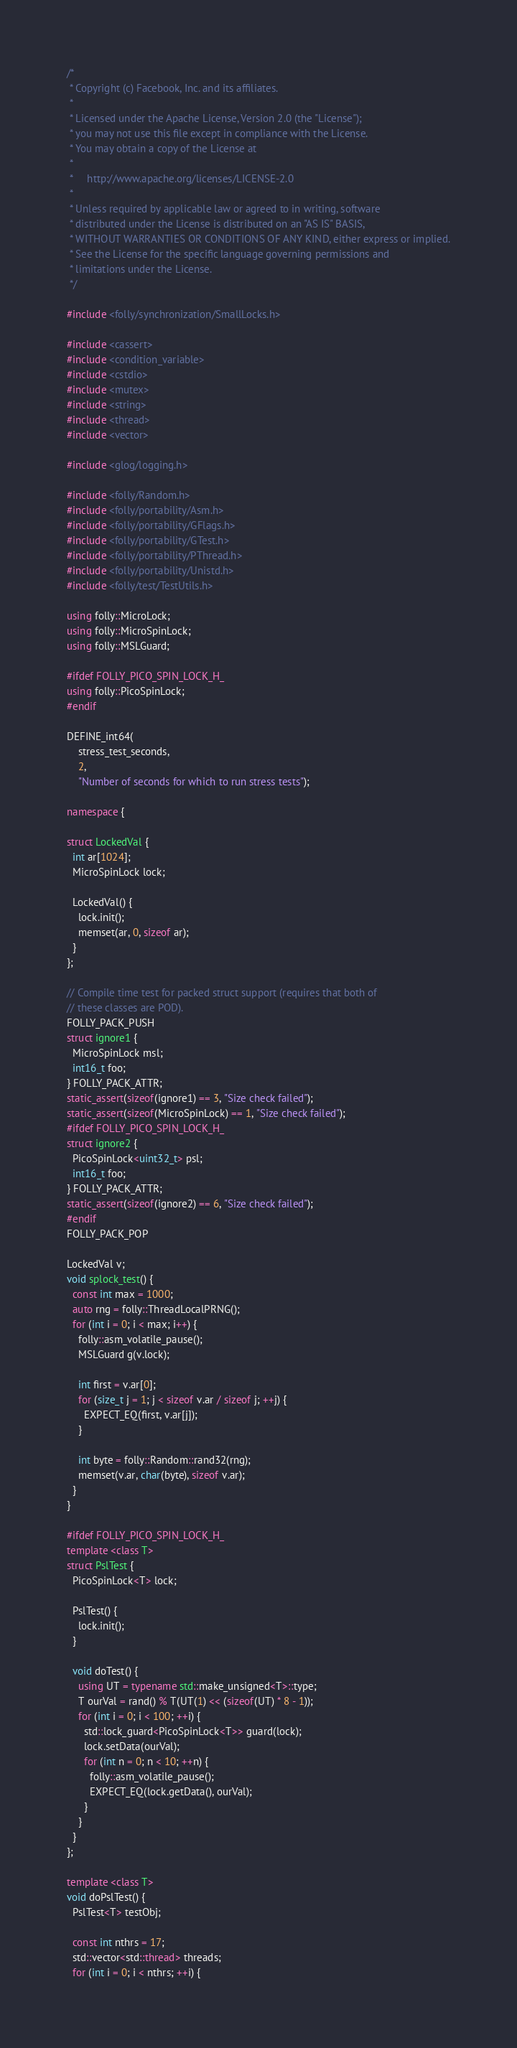Convert code to text. <code><loc_0><loc_0><loc_500><loc_500><_C++_>/*
 * Copyright (c) Facebook, Inc. and its affiliates.
 *
 * Licensed under the Apache License, Version 2.0 (the "License");
 * you may not use this file except in compliance with the License.
 * You may obtain a copy of the License at
 *
 *     http://www.apache.org/licenses/LICENSE-2.0
 *
 * Unless required by applicable law or agreed to in writing, software
 * distributed under the License is distributed on an "AS IS" BASIS,
 * WITHOUT WARRANTIES OR CONDITIONS OF ANY KIND, either express or implied.
 * See the License for the specific language governing permissions and
 * limitations under the License.
 */

#include <folly/synchronization/SmallLocks.h>

#include <cassert>
#include <condition_variable>
#include <cstdio>
#include <mutex>
#include <string>
#include <thread>
#include <vector>

#include <glog/logging.h>

#include <folly/Random.h>
#include <folly/portability/Asm.h>
#include <folly/portability/GFlags.h>
#include <folly/portability/GTest.h>
#include <folly/portability/PThread.h>
#include <folly/portability/Unistd.h>
#include <folly/test/TestUtils.h>

using folly::MicroLock;
using folly::MicroSpinLock;
using folly::MSLGuard;

#ifdef FOLLY_PICO_SPIN_LOCK_H_
using folly::PicoSpinLock;
#endif

DEFINE_int64(
    stress_test_seconds,
    2,
    "Number of seconds for which to run stress tests");

namespace {

struct LockedVal {
  int ar[1024];
  MicroSpinLock lock;

  LockedVal() {
    lock.init();
    memset(ar, 0, sizeof ar);
  }
};

// Compile time test for packed struct support (requires that both of
// these classes are POD).
FOLLY_PACK_PUSH
struct ignore1 {
  MicroSpinLock msl;
  int16_t foo;
} FOLLY_PACK_ATTR;
static_assert(sizeof(ignore1) == 3, "Size check failed");
static_assert(sizeof(MicroSpinLock) == 1, "Size check failed");
#ifdef FOLLY_PICO_SPIN_LOCK_H_
struct ignore2 {
  PicoSpinLock<uint32_t> psl;
  int16_t foo;
} FOLLY_PACK_ATTR;
static_assert(sizeof(ignore2) == 6, "Size check failed");
#endif
FOLLY_PACK_POP

LockedVal v;
void splock_test() {
  const int max = 1000;
  auto rng = folly::ThreadLocalPRNG();
  for (int i = 0; i < max; i++) {
    folly::asm_volatile_pause();
    MSLGuard g(v.lock);

    int first = v.ar[0];
    for (size_t j = 1; j < sizeof v.ar / sizeof j; ++j) {
      EXPECT_EQ(first, v.ar[j]);
    }

    int byte = folly::Random::rand32(rng);
    memset(v.ar, char(byte), sizeof v.ar);
  }
}

#ifdef FOLLY_PICO_SPIN_LOCK_H_
template <class T>
struct PslTest {
  PicoSpinLock<T> lock;

  PslTest() {
    lock.init();
  }

  void doTest() {
    using UT = typename std::make_unsigned<T>::type;
    T ourVal = rand() % T(UT(1) << (sizeof(UT) * 8 - 1));
    for (int i = 0; i < 100; ++i) {
      std::lock_guard<PicoSpinLock<T>> guard(lock);
      lock.setData(ourVal);
      for (int n = 0; n < 10; ++n) {
        folly::asm_volatile_pause();
        EXPECT_EQ(lock.getData(), ourVal);
      }
    }
  }
};

template <class T>
void doPslTest() {
  PslTest<T> testObj;

  const int nthrs = 17;
  std::vector<std::thread> threads;
  for (int i = 0; i < nthrs; ++i) {</code> 